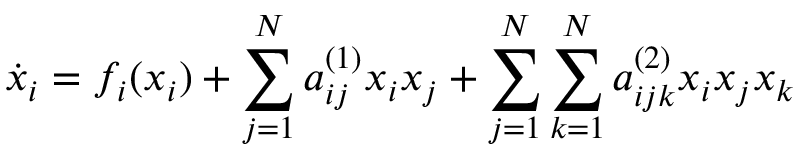<formula> <loc_0><loc_0><loc_500><loc_500>\dot { x } _ { i } = f _ { i } ( x _ { i } ) + \sum _ { j = 1 } ^ { N } a _ { i j } ^ { ( 1 ) } x _ { i } x _ { j } + \sum _ { j = 1 } ^ { N } \sum _ { k = 1 } ^ { N } a _ { i j k } ^ { ( 2 ) } x _ { i } x _ { j } x _ { k }</formula> 